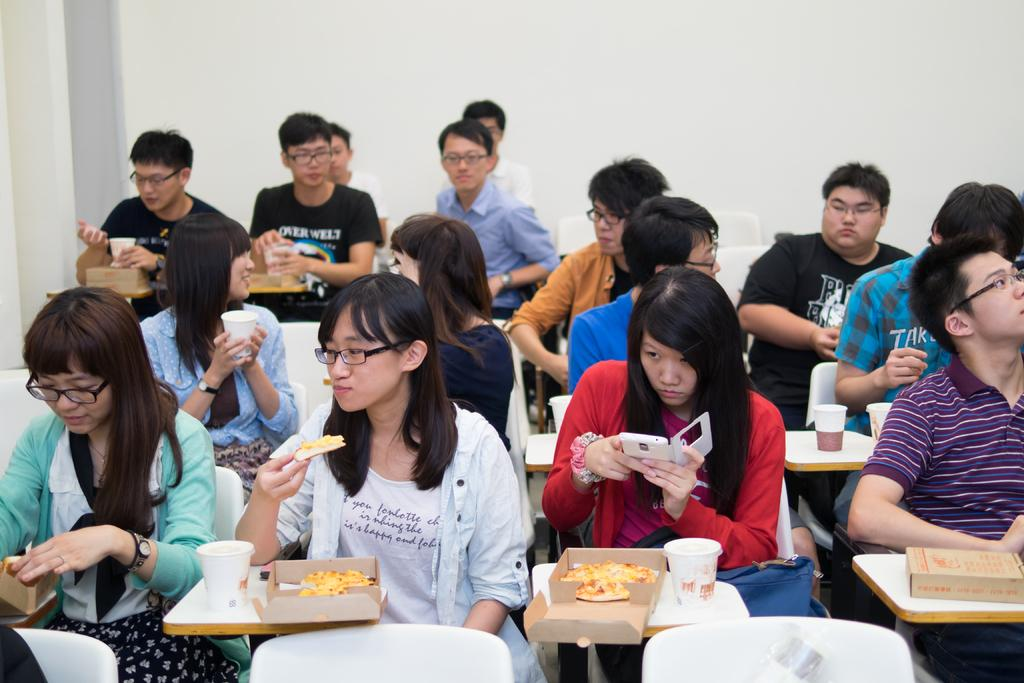What are the people in the image doing? The people in the image are sitting on chairs. What are some of the people eating? Some of the people are eating pizzas. What can be seen besides the people and pizzas in the image? There are glasses visible in the image. What is visible in the background of the image? There is a wall in the background of the image. What type of debt is being discussed by the people in the image? There is no indication in the image that the people are discussing debt; they are eating pizzas and sitting on chairs. Can you see any gloves in the image? No, there are no gloves present in the image. 